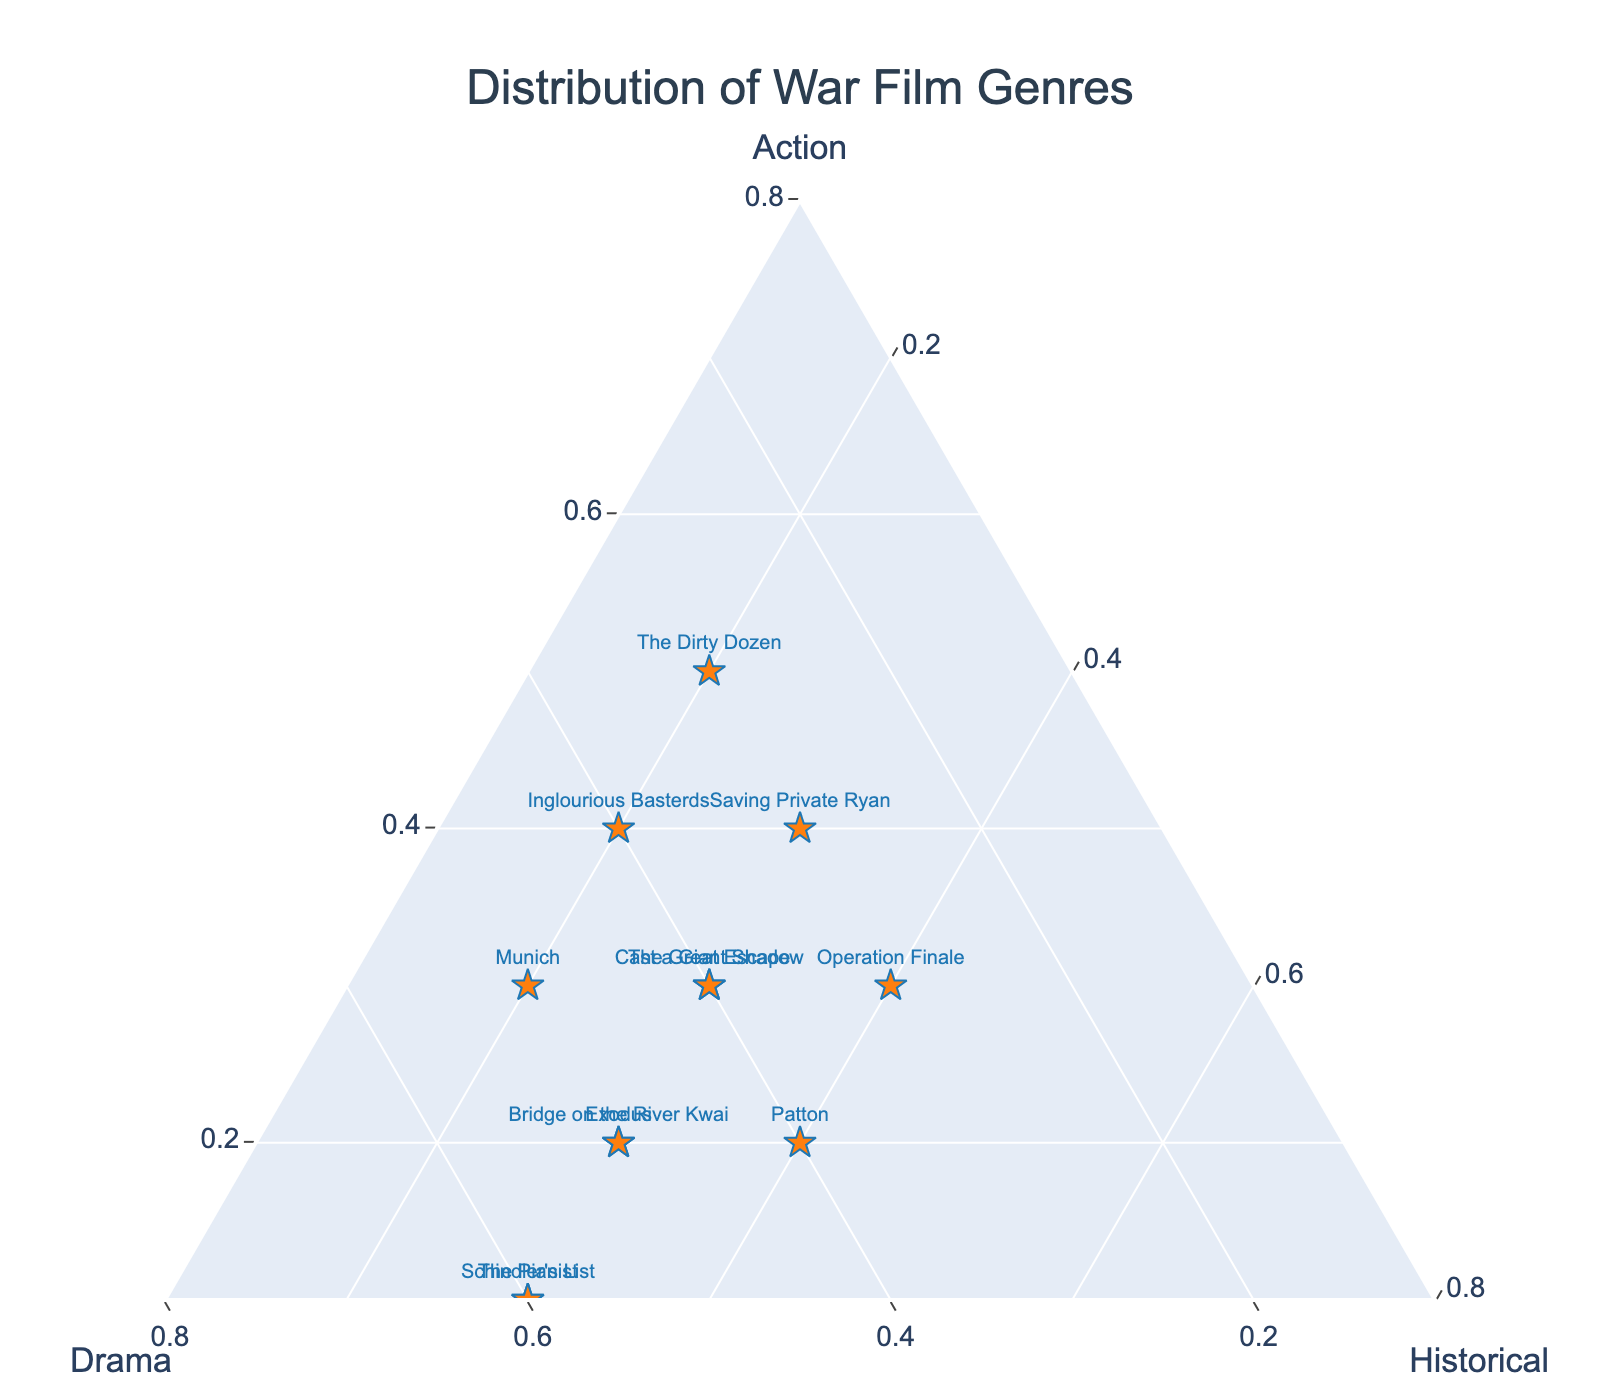What is the title of the plot? The title of the plot is displayed at the top center of the figure and should be clearly visible.
Answer: Distribution of War Film Genres How many movies have equal portions of action, drama, and historical content? Look for points that are equally distributed among the three genres, with each dimension around the same value. There are no points where action, drama, and historical content are equal (all genres at 0.33).
Answer: 0 Which movie has the highest drama proportion? Check the 'Drama' axis for the highest values and identify the corresponding movie. The highest drama proportion is seen at 0.6 for Schindler’s List and The Pianist.
Answer: Schindler's List, The Pianist Which movie has the highest historical proportion? Check the 'Historical' axis for the highest value and identify the corresponding movie. The highest historical proportion is seen at 0.4 for Patton and Operation Finale.
Answer: Patton, Operation Finale What movie has the lowest action proportion? Examine the points along the 'Action' axis for the lowest values. The lowest action proportion is 0.1 in Schindler's List and The Pianist.
Answer: Schindler's List, The Pianist Which movie is equally balanced between drama and historical genres? Look for data points where the drama and historical proportions are equal.  From the given dataset, no single movie fits this criterion since none have equal drama and historical values.
Answer: None How many movies have action as their highest genre? Count the data points where the action proportion is higher than both drama and historical. By examining the plot, The Dirty Dozen and Inglourious Basterds have action as their highest genre.
Answer: 2 Which movies have exactly 0.4 in the action genre? Identify the data points that are at 0.4 for the action genre. Reviewing the plot shows that Saving Private Ryan and Inglourious Basterds fit this criterion.
Answer: Saving Private Ryan, Inglourious Basterds If a movie is located at (Action, Drama, Historical) = (0.3, 0.5, 0.2), what's its title? Cross-check the plot for the point located at the coordinates (0.3, 0.5, 0.2). Munich has these proportions.
Answer: Munich Which movie is closest to having an even balance between its three genre proportions? Look for data points that are close to the center of the ternary plot, where the proportions of action, drama, and historical are near equal (about 0.33 each). No movie is perfectly balanced, but Saving Private Ryan with proportions (0.4, 0.3, 0.3) is the closest.
Answer: Saving Private Ryan 